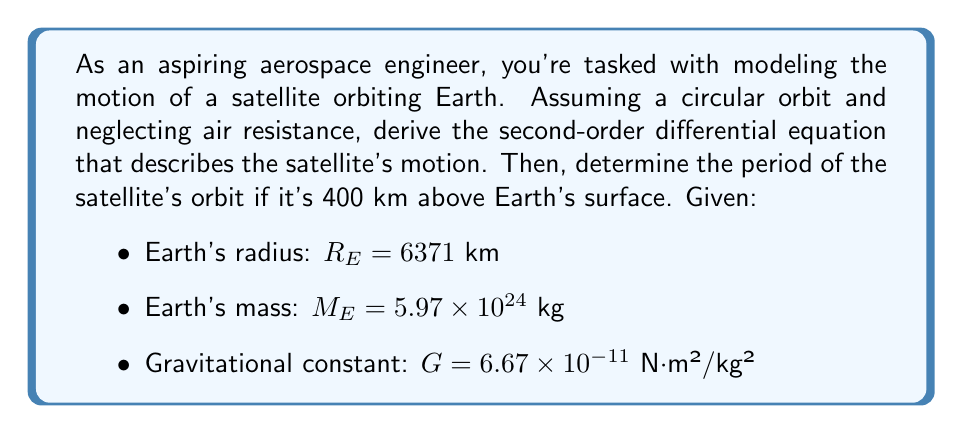Can you answer this question? Let's approach this step-by-step:

1) First, we need to derive the second-order differential equation for the satellite's motion:

   The gravitational force on the satellite is given by Newton's law of gravitation:

   $$ F = G \frac{M_E m}{r^2} $$

   where $m$ is the mass of the satellite and $r$ is its distance from Earth's center.

2) According to Newton's second law, $F = ma$, where $a$ is the centripetal acceleration:

   $$ G \frac{M_E m}{r^2} = m \frac{v^2}{r} $$

3) The velocity $v$ can be expressed as $v = r\omega$, where $\omega$ is the angular velocity:

   $$ G \frac{M_E}{r^2} = r\omega^2 $$

4) We can write $\omega = \frac{d\theta}{dt}$, so:

   $$ G \frac{M_E}{r^2} = r\left(\frac{d\theta}{dt}\right)^2 $$

5) Differentiating both sides with respect to time:

   $$ \frac{d}{dt}\left(G \frac{M_E}{r^2}\right) = \frac{d}{dt}\left(r\left(\frac{d\theta}{dt}\right)^2\right) $$

   $$ -2G M_E \frac{1}{r^3}\frac{dr}{dt} = \frac{dr}{dt}\left(\frac{d\theta}{dt}\right)^2 + 2r\frac{d\theta}{dt}\frac{d^2\theta}{dt^2} $$

6) For a circular orbit, $\frac{dr}{dt} = 0$, so we're left with:

   $$ 0 = 2r\frac{d\theta}{dt}\frac{d^2\theta}{dt^2} $$

   $$ \frac{d^2\theta}{dt^2} = 0 $$

This is our second-order differential equation describing the satellite's motion in a circular orbit.

7) To find the period, we use the equation from step 3:

   $$ \omega^2 = \frac{GM_E}{r^3} $$

8) The period $T$ is related to $\omega$ by $T = \frac{2\pi}{\omega}$, so:

   $$ T = 2\pi\sqrt{\frac{r^3}{GM_E}} $$

9) The radius $r$ is the sum of Earth's radius and the satellite's altitude:

   $$ r = R_E + 400 = 6371 + 400 = 6771 \text{ km} $$

10) Plugging in the values:

    $$ T = 2\pi\sqrt{\frac{(6771000)^3}{(6.67 \times 10^{-11})(5.97 \times 10^{24})}} $$

11) Calculating:

    $$ T \approx 5556 \text{ seconds} = 92.6 \text{ minutes} $$
Answer: The second-order differential equation describing the satellite's circular orbit is:

$$ \frac{d^2\theta}{dt^2} = 0 $$

The period of the satellite's orbit at 400 km above Earth's surface is approximately 92.6 minutes. 